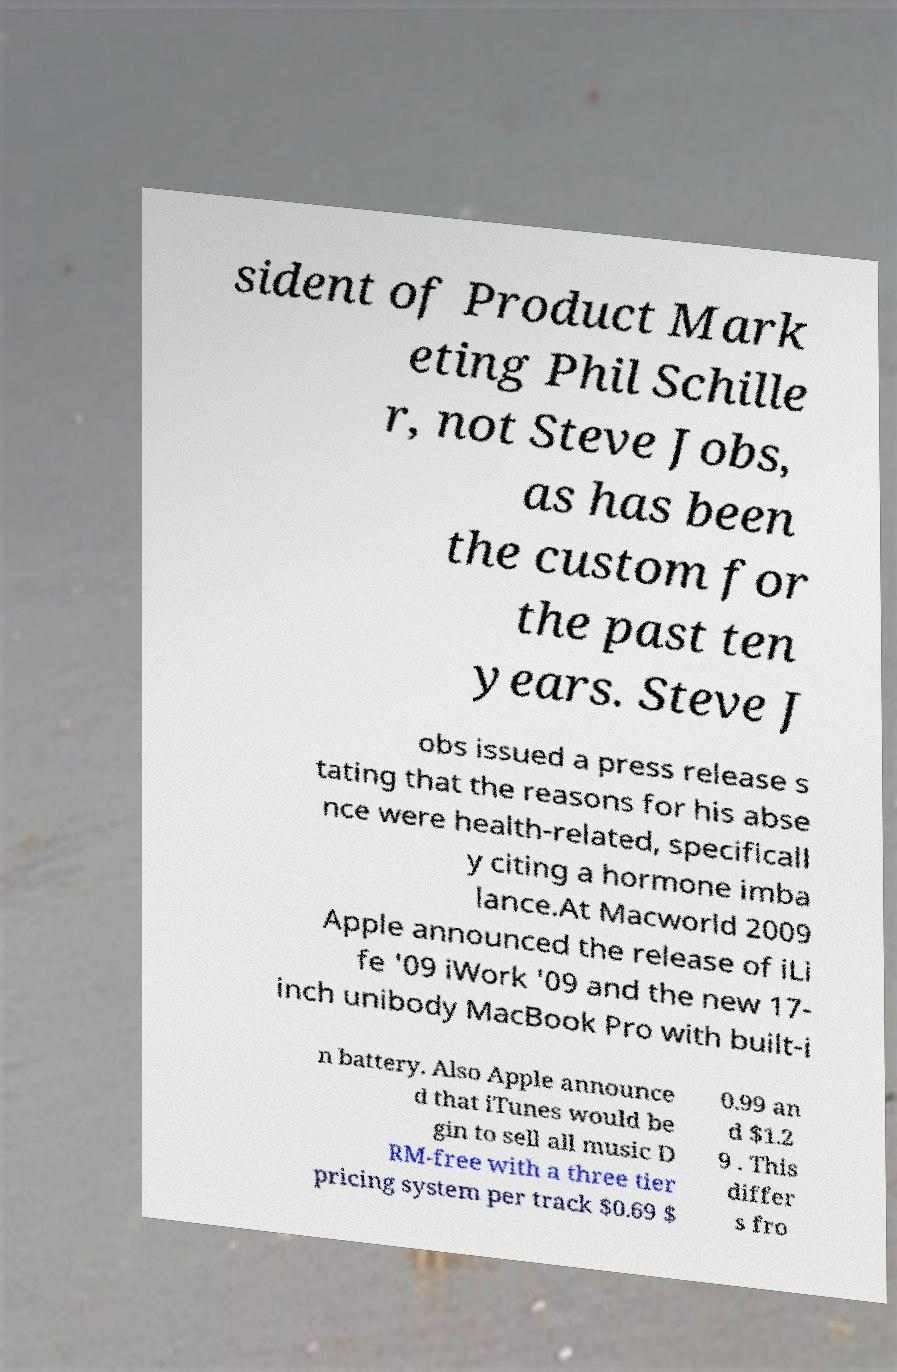Can you accurately transcribe the text from the provided image for me? sident of Product Mark eting Phil Schille r, not Steve Jobs, as has been the custom for the past ten years. Steve J obs issued a press release s tating that the reasons for his abse nce were health-related, specificall y citing a hormone imba lance.At Macworld 2009 Apple announced the release of iLi fe '09 iWork '09 and the new 17- inch unibody MacBook Pro with built-i n battery. Also Apple announce d that iTunes would be gin to sell all music D RM-free with a three tier pricing system per track $0.69 $ 0.99 an d $1.2 9 . This differ s fro 